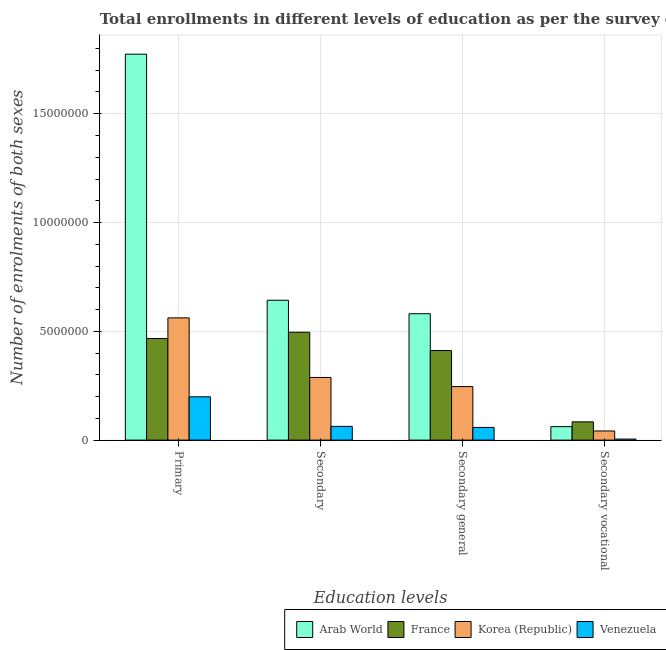How many groups of bars are there?
Make the answer very short. 4. Are the number of bars per tick equal to the number of legend labels?
Your response must be concise. Yes. What is the label of the 3rd group of bars from the left?
Make the answer very short. Secondary general. What is the number of enrolments in primary education in Arab World?
Make the answer very short. 1.77e+07. Across all countries, what is the maximum number of enrolments in primary education?
Your answer should be very brief. 1.77e+07. Across all countries, what is the minimum number of enrolments in primary education?
Offer a terse response. 1.99e+06. In which country was the number of enrolments in secondary vocational education maximum?
Your answer should be compact. France. In which country was the number of enrolments in secondary general education minimum?
Provide a short and direct response. Venezuela. What is the total number of enrolments in secondary vocational education in the graph?
Your answer should be compact. 1.93e+06. What is the difference between the number of enrolments in secondary vocational education in France and that in Venezuela?
Provide a short and direct response. 7.92e+05. What is the difference between the number of enrolments in secondary general education in Venezuela and the number of enrolments in secondary education in Arab World?
Ensure brevity in your answer.  -5.85e+06. What is the average number of enrolments in secondary education per country?
Provide a short and direct response. 3.72e+06. What is the difference between the number of enrolments in primary education and number of enrolments in secondary education in Venezuela?
Your response must be concise. 1.36e+06. In how many countries, is the number of enrolments in secondary vocational education greater than 3000000 ?
Give a very brief answer. 0. What is the ratio of the number of enrolments in secondary general education in France to that in Korea (Republic)?
Give a very brief answer. 1.67. Is the difference between the number of enrolments in primary education in Korea (Republic) and Arab World greater than the difference between the number of enrolments in secondary vocational education in Korea (Republic) and Arab World?
Offer a very short reply. No. What is the difference between the highest and the second highest number of enrolments in secondary general education?
Make the answer very short. 1.69e+06. What is the difference between the highest and the lowest number of enrolments in secondary general education?
Offer a very short reply. 5.23e+06. In how many countries, is the number of enrolments in secondary education greater than the average number of enrolments in secondary education taken over all countries?
Provide a succinct answer. 2. What does the 2nd bar from the right in Secondary represents?
Give a very brief answer. Korea (Republic). Are all the bars in the graph horizontal?
Provide a succinct answer. No. How many countries are there in the graph?
Offer a terse response. 4. What is the difference between two consecutive major ticks on the Y-axis?
Offer a terse response. 5.00e+06. Does the graph contain any zero values?
Offer a very short reply. No. How many legend labels are there?
Keep it short and to the point. 4. What is the title of the graph?
Keep it short and to the point. Total enrollments in different levels of education as per the survey of 1975. What is the label or title of the X-axis?
Give a very brief answer. Education levels. What is the label or title of the Y-axis?
Your response must be concise. Number of enrolments of both sexes. What is the Number of enrolments of both sexes of Arab World in Primary?
Keep it short and to the point. 1.77e+07. What is the Number of enrolments of both sexes of France in Primary?
Ensure brevity in your answer.  4.67e+06. What is the Number of enrolments of both sexes of Korea (Republic) in Primary?
Your answer should be compact. 5.62e+06. What is the Number of enrolments of both sexes in Venezuela in Primary?
Give a very brief answer. 1.99e+06. What is the Number of enrolments of both sexes of Arab World in Secondary?
Your response must be concise. 6.43e+06. What is the Number of enrolments of both sexes in France in Secondary?
Your response must be concise. 4.96e+06. What is the Number of enrolments of both sexes in Korea (Republic) in Secondary?
Provide a short and direct response. 2.88e+06. What is the Number of enrolments of both sexes of Venezuela in Secondary?
Provide a succinct answer. 6.31e+05. What is the Number of enrolments of both sexes in Arab World in Secondary general?
Ensure brevity in your answer.  5.81e+06. What is the Number of enrolments of both sexes of France in Secondary general?
Provide a succinct answer. 4.12e+06. What is the Number of enrolments of both sexes in Korea (Republic) in Secondary general?
Ensure brevity in your answer.  2.46e+06. What is the Number of enrolments of both sexes of Venezuela in Secondary general?
Offer a terse response. 5.83e+05. What is the Number of enrolments of both sexes of Arab World in Secondary vocational?
Provide a succinct answer. 6.20e+05. What is the Number of enrolments of both sexes of France in Secondary vocational?
Provide a short and direct response. 8.40e+05. What is the Number of enrolments of both sexes in Korea (Republic) in Secondary vocational?
Your response must be concise. 4.20e+05. What is the Number of enrolments of both sexes in Venezuela in Secondary vocational?
Offer a very short reply. 4.80e+04. Across all Education levels, what is the maximum Number of enrolments of both sexes in Arab World?
Your response must be concise. 1.77e+07. Across all Education levels, what is the maximum Number of enrolments of both sexes of France?
Provide a short and direct response. 4.96e+06. Across all Education levels, what is the maximum Number of enrolments of both sexes of Korea (Republic)?
Offer a terse response. 5.62e+06. Across all Education levels, what is the maximum Number of enrolments of both sexes in Venezuela?
Your response must be concise. 1.99e+06. Across all Education levels, what is the minimum Number of enrolments of both sexes in Arab World?
Provide a short and direct response. 6.20e+05. Across all Education levels, what is the minimum Number of enrolments of both sexes in France?
Offer a very short reply. 8.40e+05. Across all Education levels, what is the minimum Number of enrolments of both sexes in Korea (Republic)?
Keep it short and to the point. 4.20e+05. Across all Education levels, what is the minimum Number of enrolments of both sexes of Venezuela?
Offer a terse response. 4.80e+04. What is the total Number of enrolments of both sexes of Arab World in the graph?
Offer a very short reply. 3.06e+07. What is the total Number of enrolments of both sexes of France in the graph?
Provide a succinct answer. 1.46e+07. What is the total Number of enrolments of both sexes in Korea (Republic) in the graph?
Ensure brevity in your answer.  1.14e+07. What is the total Number of enrolments of both sexes in Venezuela in the graph?
Provide a short and direct response. 3.25e+06. What is the difference between the Number of enrolments of both sexes in Arab World in Primary and that in Secondary?
Provide a short and direct response. 1.13e+07. What is the difference between the Number of enrolments of both sexes in France in Primary and that in Secondary?
Your answer should be compact. -2.87e+05. What is the difference between the Number of enrolments of both sexes in Korea (Republic) in Primary and that in Secondary?
Your response must be concise. 2.74e+06. What is the difference between the Number of enrolments of both sexes of Venezuela in Primary and that in Secondary?
Provide a succinct answer. 1.36e+06. What is the difference between the Number of enrolments of both sexes of Arab World in Primary and that in Secondary general?
Make the answer very short. 1.19e+07. What is the difference between the Number of enrolments of both sexes in France in Primary and that in Secondary general?
Keep it short and to the point. 5.53e+05. What is the difference between the Number of enrolments of both sexes of Korea (Republic) in Primary and that in Secondary general?
Provide a succinct answer. 3.16e+06. What is the difference between the Number of enrolments of both sexes of Venezuela in Primary and that in Secondary general?
Your answer should be compact. 1.41e+06. What is the difference between the Number of enrolments of both sexes in Arab World in Primary and that in Secondary vocational?
Offer a very short reply. 1.71e+07. What is the difference between the Number of enrolments of both sexes in France in Primary and that in Secondary vocational?
Provide a short and direct response. 3.83e+06. What is the difference between the Number of enrolments of both sexes in Korea (Republic) in Primary and that in Secondary vocational?
Ensure brevity in your answer.  5.20e+06. What is the difference between the Number of enrolments of both sexes of Venezuela in Primary and that in Secondary vocational?
Provide a succinct answer. 1.94e+06. What is the difference between the Number of enrolments of both sexes in Arab World in Secondary and that in Secondary general?
Give a very brief answer. 6.20e+05. What is the difference between the Number of enrolments of both sexes in France in Secondary and that in Secondary general?
Provide a succinct answer. 8.40e+05. What is the difference between the Number of enrolments of both sexes of Korea (Republic) in Secondary and that in Secondary general?
Your answer should be very brief. 4.20e+05. What is the difference between the Number of enrolments of both sexes in Venezuela in Secondary and that in Secondary general?
Your answer should be very brief. 4.80e+04. What is the difference between the Number of enrolments of both sexes in Arab World in Secondary and that in Secondary vocational?
Give a very brief answer. 5.81e+06. What is the difference between the Number of enrolments of both sexes of France in Secondary and that in Secondary vocational?
Make the answer very short. 4.12e+06. What is the difference between the Number of enrolments of both sexes in Korea (Republic) in Secondary and that in Secondary vocational?
Ensure brevity in your answer.  2.46e+06. What is the difference between the Number of enrolments of both sexes in Venezuela in Secondary and that in Secondary vocational?
Make the answer very short. 5.83e+05. What is the difference between the Number of enrolments of both sexes of Arab World in Secondary general and that in Secondary vocational?
Give a very brief answer. 5.19e+06. What is the difference between the Number of enrolments of both sexes in France in Secondary general and that in Secondary vocational?
Offer a very short reply. 3.28e+06. What is the difference between the Number of enrolments of both sexes of Korea (Republic) in Secondary general and that in Secondary vocational?
Make the answer very short. 2.04e+06. What is the difference between the Number of enrolments of both sexes of Venezuela in Secondary general and that in Secondary vocational?
Make the answer very short. 5.35e+05. What is the difference between the Number of enrolments of both sexes in Arab World in Primary and the Number of enrolments of both sexes in France in Secondary?
Ensure brevity in your answer.  1.28e+07. What is the difference between the Number of enrolments of both sexes in Arab World in Primary and the Number of enrolments of both sexes in Korea (Republic) in Secondary?
Offer a terse response. 1.49e+07. What is the difference between the Number of enrolments of both sexes of Arab World in Primary and the Number of enrolments of both sexes of Venezuela in Secondary?
Your response must be concise. 1.71e+07. What is the difference between the Number of enrolments of both sexes of France in Primary and the Number of enrolments of both sexes of Korea (Republic) in Secondary?
Offer a very short reply. 1.79e+06. What is the difference between the Number of enrolments of both sexes of France in Primary and the Number of enrolments of both sexes of Venezuela in Secondary?
Your response must be concise. 4.04e+06. What is the difference between the Number of enrolments of both sexes of Korea (Republic) in Primary and the Number of enrolments of both sexes of Venezuela in Secondary?
Your answer should be very brief. 4.99e+06. What is the difference between the Number of enrolments of both sexes of Arab World in Primary and the Number of enrolments of both sexes of France in Secondary general?
Your answer should be compact. 1.36e+07. What is the difference between the Number of enrolments of both sexes in Arab World in Primary and the Number of enrolments of both sexes in Korea (Republic) in Secondary general?
Offer a terse response. 1.53e+07. What is the difference between the Number of enrolments of both sexes in Arab World in Primary and the Number of enrolments of both sexes in Venezuela in Secondary general?
Provide a short and direct response. 1.72e+07. What is the difference between the Number of enrolments of both sexes in France in Primary and the Number of enrolments of both sexes in Korea (Republic) in Secondary general?
Give a very brief answer. 2.21e+06. What is the difference between the Number of enrolments of both sexes of France in Primary and the Number of enrolments of both sexes of Venezuela in Secondary general?
Your answer should be compact. 4.09e+06. What is the difference between the Number of enrolments of both sexes in Korea (Republic) in Primary and the Number of enrolments of both sexes in Venezuela in Secondary general?
Offer a very short reply. 5.04e+06. What is the difference between the Number of enrolments of both sexes of Arab World in Primary and the Number of enrolments of both sexes of France in Secondary vocational?
Provide a succinct answer. 1.69e+07. What is the difference between the Number of enrolments of both sexes in Arab World in Primary and the Number of enrolments of both sexes in Korea (Republic) in Secondary vocational?
Provide a succinct answer. 1.73e+07. What is the difference between the Number of enrolments of both sexes of Arab World in Primary and the Number of enrolments of both sexes of Venezuela in Secondary vocational?
Your answer should be very brief. 1.77e+07. What is the difference between the Number of enrolments of both sexes of France in Primary and the Number of enrolments of both sexes of Korea (Republic) in Secondary vocational?
Give a very brief answer. 4.25e+06. What is the difference between the Number of enrolments of both sexes in France in Primary and the Number of enrolments of both sexes in Venezuela in Secondary vocational?
Ensure brevity in your answer.  4.62e+06. What is the difference between the Number of enrolments of both sexes in Korea (Republic) in Primary and the Number of enrolments of both sexes in Venezuela in Secondary vocational?
Offer a terse response. 5.57e+06. What is the difference between the Number of enrolments of both sexes in Arab World in Secondary and the Number of enrolments of both sexes in France in Secondary general?
Offer a terse response. 2.31e+06. What is the difference between the Number of enrolments of both sexes in Arab World in Secondary and the Number of enrolments of both sexes in Korea (Republic) in Secondary general?
Your answer should be very brief. 3.97e+06. What is the difference between the Number of enrolments of both sexes in Arab World in Secondary and the Number of enrolments of both sexes in Venezuela in Secondary general?
Offer a terse response. 5.85e+06. What is the difference between the Number of enrolments of both sexes of France in Secondary and the Number of enrolments of both sexes of Korea (Republic) in Secondary general?
Provide a succinct answer. 2.50e+06. What is the difference between the Number of enrolments of both sexes of France in Secondary and the Number of enrolments of both sexes of Venezuela in Secondary general?
Offer a very short reply. 4.37e+06. What is the difference between the Number of enrolments of both sexes in Korea (Republic) in Secondary and the Number of enrolments of both sexes in Venezuela in Secondary general?
Offer a very short reply. 2.30e+06. What is the difference between the Number of enrolments of both sexes in Arab World in Secondary and the Number of enrolments of both sexes in France in Secondary vocational?
Keep it short and to the point. 5.59e+06. What is the difference between the Number of enrolments of both sexes of Arab World in Secondary and the Number of enrolments of both sexes of Korea (Republic) in Secondary vocational?
Keep it short and to the point. 6.01e+06. What is the difference between the Number of enrolments of both sexes in Arab World in Secondary and the Number of enrolments of both sexes in Venezuela in Secondary vocational?
Make the answer very short. 6.38e+06. What is the difference between the Number of enrolments of both sexes of France in Secondary and the Number of enrolments of both sexes of Korea (Republic) in Secondary vocational?
Provide a succinct answer. 4.54e+06. What is the difference between the Number of enrolments of both sexes of France in Secondary and the Number of enrolments of both sexes of Venezuela in Secondary vocational?
Offer a very short reply. 4.91e+06. What is the difference between the Number of enrolments of both sexes of Korea (Republic) in Secondary and the Number of enrolments of both sexes of Venezuela in Secondary vocational?
Your answer should be compact. 2.83e+06. What is the difference between the Number of enrolments of both sexes of Arab World in Secondary general and the Number of enrolments of both sexes of France in Secondary vocational?
Your response must be concise. 4.97e+06. What is the difference between the Number of enrolments of both sexes in Arab World in Secondary general and the Number of enrolments of both sexes in Korea (Republic) in Secondary vocational?
Offer a terse response. 5.39e+06. What is the difference between the Number of enrolments of both sexes in Arab World in Secondary general and the Number of enrolments of both sexes in Venezuela in Secondary vocational?
Make the answer very short. 5.76e+06. What is the difference between the Number of enrolments of both sexes in France in Secondary general and the Number of enrolments of both sexes in Korea (Republic) in Secondary vocational?
Offer a very short reply. 3.70e+06. What is the difference between the Number of enrolments of both sexes in France in Secondary general and the Number of enrolments of both sexes in Venezuela in Secondary vocational?
Your response must be concise. 4.07e+06. What is the difference between the Number of enrolments of both sexes of Korea (Republic) in Secondary general and the Number of enrolments of both sexes of Venezuela in Secondary vocational?
Make the answer very short. 2.41e+06. What is the average Number of enrolments of both sexes of Arab World per Education levels?
Give a very brief answer. 7.65e+06. What is the average Number of enrolments of both sexes of France per Education levels?
Ensure brevity in your answer.  3.65e+06. What is the average Number of enrolments of both sexes in Korea (Republic) per Education levels?
Your answer should be very brief. 2.84e+06. What is the average Number of enrolments of both sexes in Venezuela per Education levels?
Ensure brevity in your answer.  8.13e+05. What is the difference between the Number of enrolments of both sexes in Arab World and Number of enrolments of both sexes in France in Primary?
Your answer should be very brief. 1.31e+07. What is the difference between the Number of enrolments of both sexes in Arab World and Number of enrolments of both sexes in Korea (Republic) in Primary?
Your response must be concise. 1.21e+07. What is the difference between the Number of enrolments of both sexes in Arab World and Number of enrolments of both sexes in Venezuela in Primary?
Ensure brevity in your answer.  1.57e+07. What is the difference between the Number of enrolments of both sexes of France and Number of enrolments of both sexes of Korea (Republic) in Primary?
Keep it short and to the point. -9.48e+05. What is the difference between the Number of enrolments of both sexes of France and Number of enrolments of both sexes of Venezuela in Primary?
Keep it short and to the point. 2.68e+06. What is the difference between the Number of enrolments of both sexes of Korea (Republic) and Number of enrolments of both sexes of Venezuela in Primary?
Offer a terse response. 3.63e+06. What is the difference between the Number of enrolments of both sexes in Arab World and Number of enrolments of both sexes in France in Secondary?
Provide a succinct answer. 1.47e+06. What is the difference between the Number of enrolments of both sexes of Arab World and Number of enrolments of both sexes of Korea (Republic) in Secondary?
Your answer should be compact. 3.55e+06. What is the difference between the Number of enrolments of both sexes of Arab World and Number of enrolments of both sexes of Venezuela in Secondary?
Your response must be concise. 5.80e+06. What is the difference between the Number of enrolments of both sexes of France and Number of enrolments of both sexes of Korea (Republic) in Secondary?
Provide a short and direct response. 2.08e+06. What is the difference between the Number of enrolments of both sexes in France and Number of enrolments of both sexes in Venezuela in Secondary?
Your answer should be compact. 4.33e+06. What is the difference between the Number of enrolments of both sexes in Korea (Republic) and Number of enrolments of both sexes in Venezuela in Secondary?
Give a very brief answer. 2.25e+06. What is the difference between the Number of enrolments of both sexes in Arab World and Number of enrolments of both sexes in France in Secondary general?
Ensure brevity in your answer.  1.69e+06. What is the difference between the Number of enrolments of both sexes in Arab World and Number of enrolments of both sexes in Korea (Republic) in Secondary general?
Your answer should be compact. 3.35e+06. What is the difference between the Number of enrolments of both sexes of Arab World and Number of enrolments of both sexes of Venezuela in Secondary general?
Offer a terse response. 5.23e+06. What is the difference between the Number of enrolments of both sexes of France and Number of enrolments of both sexes of Korea (Republic) in Secondary general?
Offer a terse response. 1.66e+06. What is the difference between the Number of enrolments of both sexes of France and Number of enrolments of both sexes of Venezuela in Secondary general?
Provide a succinct answer. 3.53e+06. What is the difference between the Number of enrolments of both sexes in Korea (Republic) and Number of enrolments of both sexes in Venezuela in Secondary general?
Offer a very short reply. 1.88e+06. What is the difference between the Number of enrolments of both sexes in Arab World and Number of enrolments of both sexes in France in Secondary vocational?
Ensure brevity in your answer.  -2.20e+05. What is the difference between the Number of enrolments of both sexes in Arab World and Number of enrolments of both sexes in Korea (Republic) in Secondary vocational?
Give a very brief answer. 2.00e+05. What is the difference between the Number of enrolments of both sexes of Arab World and Number of enrolments of both sexes of Venezuela in Secondary vocational?
Ensure brevity in your answer.  5.72e+05. What is the difference between the Number of enrolments of both sexes in France and Number of enrolments of both sexes in Korea (Republic) in Secondary vocational?
Ensure brevity in your answer.  4.20e+05. What is the difference between the Number of enrolments of both sexes in France and Number of enrolments of both sexes in Venezuela in Secondary vocational?
Your response must be concise. 7.92e+05. What is the difference between the Number of enrolments of both sexes of Korea (Republic) and Number of enrolments of both sexes of Venezuela in Secondary vocational?
Offer a very short reply. 3.72e+05. What is the ratio of the Number of enrolments of both sexes of Arab World in Primary to that in Secondary?
Your response must be concise. 2.76. What is the ratio of the Number of enrolments of both sexes of France in Primary to that in Secondary?
Offer a terse response. 0.94. What is the ratio of the Number of enrolments of both sexes of Korea (Republic) in Primary to that in Secondary?
Ensure brevity in your answer.  1.95. What is the ratio of the Number of enrolments of both sexes of Venezuela in Primary to that in Secondary?
Ensure brevity in your answer.  3.15. What is the ratio of the Number of enrolments of both sexes in Arab World in Primary to that in Secondary general?
Keep it short and to the point. 3.05. What is the ratio of the Number of enrolments of both sexes in France in Primary to that in Secondary general?
Your answer should be very brief. 1.13. What is the ratio of the Number of enrolments of both sexes in Korea (Republic) in Primary to that in Secondary general?
Ensure brevity in your answer.  2.28. What is the ratio of the Number of enrolments of both sexes in Venezuela in Primary to that in Secondary general?
Provide a succinct answer. 3.41. What is the ratio of the Number of enrolments of both sexes in Arab World in Primary to that in Secondary vocational?
Offer a very short reply. 28.63. What is the ratio of the Number of enrolments of both sexes of France in Primary to that in Secondary vocational?
Ensure brevity in your answer.  5.56. What is the ratio of the Number of enrolments of both sexes in Korea (Republic) in Primary to that in Secondary vocational?
Offer a terse response. 13.38. What is the ratio of the Number of enrolments of both sexes in Venezuela in Primary to that in Secondary vocational?
Provide a succinct answer. 41.42. What is the ratio of the Number of enrolments of both sexes of Arab World in Secondary to that in Secondary general?
Offer a terse response. 1.11. What is the ratio of the Number of enrolments of both sexes of France in Secondary to that in Secondary general?
Make the answer very short. 1.2. What is the ratio of the Number of enrolments of both sexes of Korea (Republic) in Secondary to that in Secondary general?
Give a very brief answer. 1.17. What is the ratio of the Number of enrolments of both sexes of Venezuela in Secondary to that in Secondary general?
Your answer should be compact. 1.08. What is the ratio of the Number of enrolments of both sexes of Arab World in Secondary to that in Secondary vocational?
Keep it short and to the point. 10.38. What is the ratio of the Number of enrolments of both sexes of France in Secondary to that in Secondary vocational?
Provide a succinct answer. 5.9. What is the ratio of the Number of enrolments of both sexes of Korea (Republic) in Secondary to that in Secondary vocational?
Ensure brevity in your answer.  6.86. What is the ratio of the Number of enrolments of both sexes of Venezuela in Secondary to that in Secondary vocational?
Ensure brevity in your answer.  13.14. What is the ratio of the Number of enrolments of both sexes in Arab World in Secondary general to that in Secondary vocational?
Your answer should be compact. 9.38. What is the ratio of the Number of enrolments of both sexes in France in Secondary general to that in Secondary vocational?
Keep it short and to the point. 4.9. What is the ratio of the Number of enrolments of both sexes of Korea (Republic) in Secondary general to that in Secondary vocational?
Your answer should be very brief. 5.86. What is the ratio of the Number of enrolments of both sexes in Venezuela in Secondary general to that in Secondary vocational?
Your answer should be very brief. 12.14. What is the difference between the highest and the second highest Number of enrolments of both sexes of Arab World?
Keep it short and to the point. 1.13e+07. What is the difference between the highest and the second highest Number of enrolments of both sexes of France?
Provide a short and direct response. 2.87e+05. What is the difference between the highest and the second highest Number of enrolments of both sexes in Korea (Republic)?
Your answer should be very brief. 2.74e+06. What is the difference between the highest and the second highest Number of enrolments of both sexes of Venezuela?
Make the answer very short. 1.36e+06. What is the difference between the highest and the lowest Number of enrolments of both sexes in Arab World?
Your response must be concise. 1.71e+07. What is the difference between the highest and the lowest Number of enrolments of both sexes in France?
Offer a terse response. 4.12e+06. What is the difference between the highest and the lowest Number of enrolments of both sexes in Korea (Republic)?
Ensure brevity in your answer.  5.20e+06. What is the difference between the highest and the lowest Number of enrolments of both sexes of Venezuela?
Make the answer very short. 1.94e+06. 